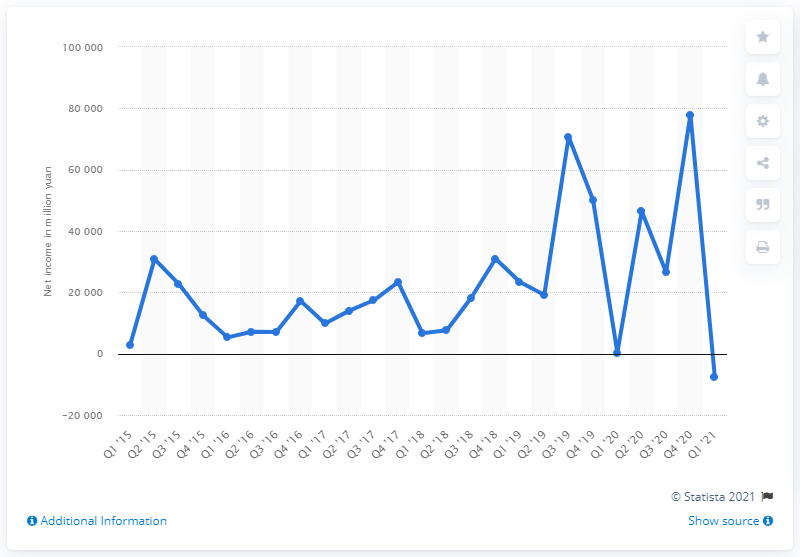Mention a couple of crucial points in this snapshot. Alibaba reported a net loss of 7,650 in the first quarter of 2021. 